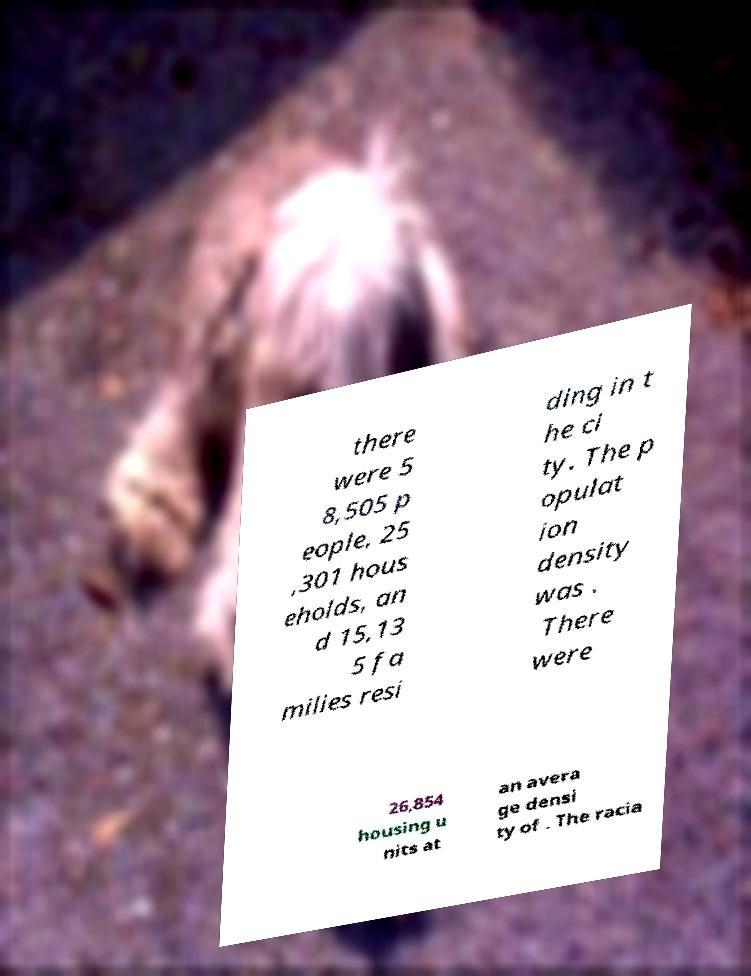I need the written content from this picture converted into text. Can you do that? there were 5 8,505 p eople, 25 ,301 hous eholds, an d 15,13 5 fa milies resi ding in t he ci ty. The p opulat ion density was . There were 26,854 housing u nits at an avera ge densi ty of . The racia 